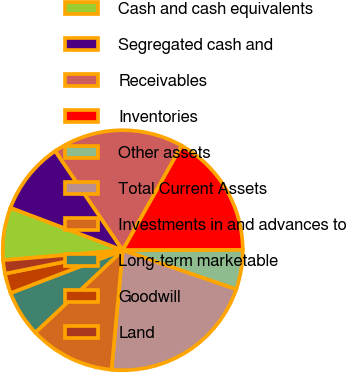Convert chart to OTSL. <chart><loc_0><loc_0><loc_500><loc_500><pie_chart><fcel>Cash and cash equivalents<fcel>Segregated cash and<fcel>Receivables<fcel>Inventories<fcel>Other assets<fcel>Total Current Assets<fcel>Investments in and advances to<fcel>Long-term marketable<fcel>Goodwill<fcel>Land<nl><fcel>7.09%<fcel>9.74%<fcel>17.67%<fcel>16.79%<fcel>5.33%<fcel>21.2%<fcel>11.5%<fcel>6.21%<fcel>2.68%<fcel>1.8%<nl></chart> 